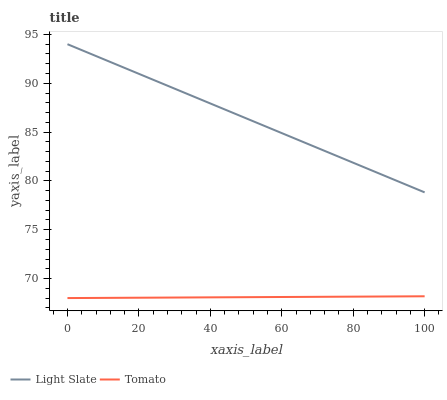Does Tomato have the minimum area under the curve?
Answer yes or no. Yes. Does Light Slate have the maximum area under the curve?
Answer yes or no. Yes. Does Tomato have the maximum area under the curve?
Answer yes or no. No. Is Light Slate the smoothest?
Answer yes or no. Yes. Is Tomato the roughest?
Answer yes or no. Yes. Is Tomato the smoothest?
Answer yes or no. No. Does Tomato have the lowest value?
Answer yes or no. Yes. Does Light Slate have the highest value?
Answer yes or no. Yes. Does Tomato have the highest value?
Answer yes or no. No. Is Tomato less than Light Slate?
Answer yes or no. Yes. Is Light Slate greater than Tomato?
Answer yes or no. Yes. Does Tomato intersect Light Slate?
Answer yes or no. No. 